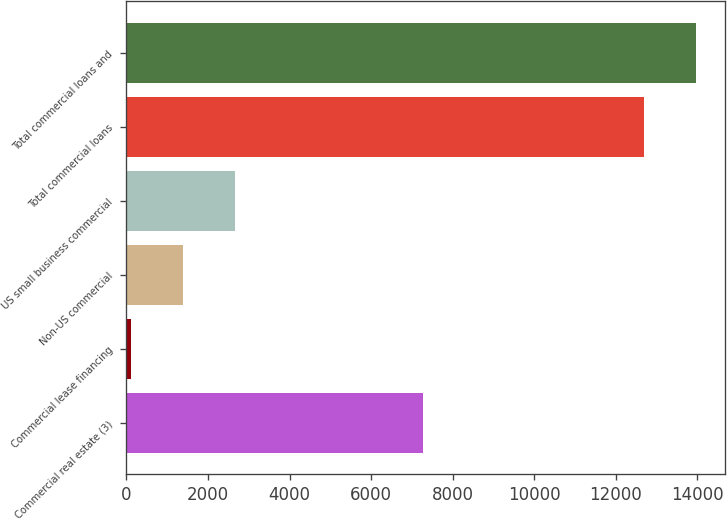Convert chart. <chart><loc_0><loc_0><loc_500><loc_500><bar_chart><fcel>Commercial real estate (3)<fcel>Commercial lease financing<fcel>Non-US commercial<fcel>US small business commercial<fcel>Total commercial loans<fcel>Total commercial loans and<nl><fcel>7286<fcel>115<fcel>1387.6<fcel>2660.2<fcel>12703<fcel>13975.6<nl></chart> 